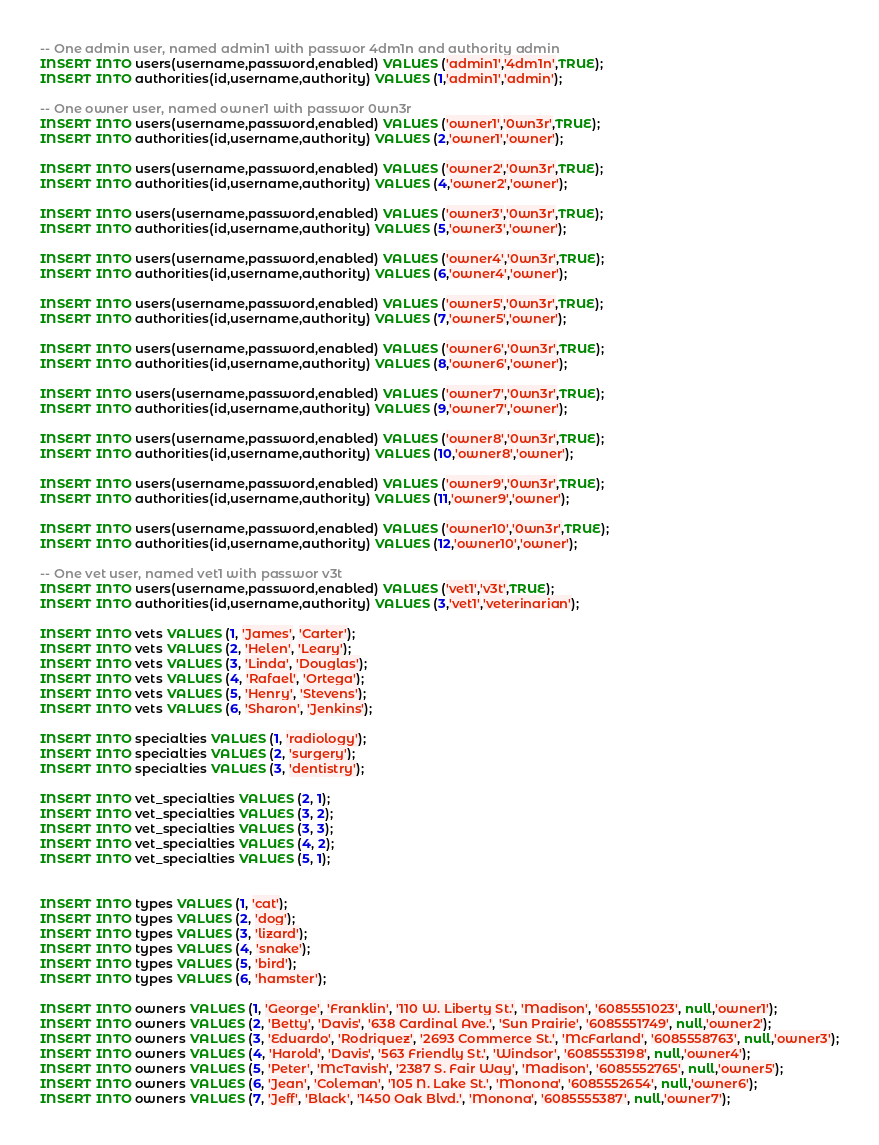<code> <loc_0><loc_0><loc_500><loc_500><_SQL_>-- One admin user, named admin1 with passwor 4dm1n and authority admin
INSERT INTO users(username,password,enabled) VALUES ('admin1','4dm1n',TRUE);
INSERT INTO authorities(id,username,authority) VALUES (1,'admin1','admin');

-- One owner user, named owner1 with passwor 0wn3r
INSERT INTO users(username,password,enabled) VALUES ('owner1','0wn3r',TRUE);
INSERT INTO authorities(id,username,authority) VALUES (2,'owner1','owner');

INSERT INTO users(username,password,enabled) VALUES ('owner2','0wn3r',TRUE);
INSERT INTO authorities(id,username,authority) VALUES (4,'owner2','owner');

INSERT INTO users(username,password,enabled) VALUES ('owner3','0wn3r',TRUE);
INSERT INTO authorities(id,username,authority) VALUES (5,'owner3','owner');

INSERT INTO users(username,password,enabled) VALUES ('owner4','0wn3r',TRUE);
INSERT INTO authorities(id,username,authority) VALUES (6,'owner4','owner');

INSERT INTO users(username,password,enabled) VALUES ('owner5','0wn3r',TRUE);
INSERT INTO authorities(id,username,authority) VALUES (7,'owner5','owner');

INSERT INTO users(username,password,enabled) VALUES ('owner6','0wn3r',TRUE);
INSERT INTO authorities(id,username,authority) VALUES (8,'owner6','owner');

INSERT INTO users(username,password,enabled) VALUES ('owner7','0wn3r',TRUE);
INSERT INTO authorities(id,username,authority) VALUES (9,'owner7','owner');

INSERT INTO users(username,password,enabled) VALUES ('owner8','0wn3r',TRUE);
INSERT INTO authorities(id,username,authority) VALUES (10,'owner8','owner');

INSERT INTO users(username,password,enabled) VALUES ('owner9','0wn3r',TRUE);
INSERT INTO authorities(id,username,authority) VALUES (11,'owner9','owner');

INSERT INTO users(username,password,enabled) VALUES ('owner10','0wn3r',TRUE);
INSERT INTO authorities(id,username,authority) VALUES (12,'owner10','owner');

-- One vet user, named vet1 with passwor v3t
INSERT INTO users(username,password,enabled) VALUES ('vet1','v3t',TRUE);
INSERT INTO authorities(id,username,authority) VALUES (3,'vet1','veterinarian');

INSERT INTO vets VALUES (1, 'James', 'Carter');
INSERT INTO vets VALUES (2, 'Helen', 'Leary');
INSERT INTO vets VALUES (3, 'Linda', 'Douglas');
INSERT INTO vets VALUES (4, 'Rafael', 'Ortega');
INSERT INTO vets VALUES (5, 'Henry', 'Stevens');
INSERT INTO vets VALUES (6, 'Sharon', 'Jenkins');

INSERT INTO specialties VALUES (1, 'radiology');
INSERT INTO specialties VALUES (2, 'surgery');
INSERT INTO specialties VALUES (3, 'dentistry');

INSERT INTO vet_specialties VALUES (2, 1);
INSERT INTO vet_specialties VALUES (3, 2);
INSERT INTO vet_specialties VALUES (3, 3);
INSERT INTO vet_specialties VALUES (4, 2);
INSERT INTO vet_specialties VALUES (5, 1);


INSERT INTO types VALUES (1, 'cat');
INSERT INTO types VALUES (2, 'dog');
INSERT INTO types VALUES (3, 'lizard');
INSERT INTO types VALUES (4, 'snake');
INSERT INTO types VALUES (5, 'bird');
INSERT INTO types VALUES (6, 'hamster');

INSERT INTO owners VALUES (1, 'George', 'Franklin', '110 W. Liberty St.', 'Madison', '6085551023', null,'owner1');
INSERT INTO owners VALUES (2, 'Betty', 'Davis', '638 Cardinal Ave.', 'Sun Prairie', '6085551749', null,'owner2');
INSERT INTO owners VALUES (3, 'Eduardo', 'Rodriquez', '2693 Commerce St.', 'McFarland', '6085558763', null,'owner3');
INSERT INTO owners VALUES (4, 'Harold', 'Davis', '563 Friendly St.', 'Windsor', '6085553198', null,'owner4');
INSERT INTO owners VALUES (5, 'Peter', 'McTavish', '2387 S. Fair Way', 'Madison', '6085552765', null,'owner5');
INSERT INTO owners VALUES (6, 'Jean', 'Coleman', '105 N. Lake St.', 'Monona', '6085552654', null,'owner6');
INSERT INTO owners VALUES (7, 'Jeff', 'Black', '1450 Oak Blvd.', 'Monona', '6085555387', null,'owner7');</code> 